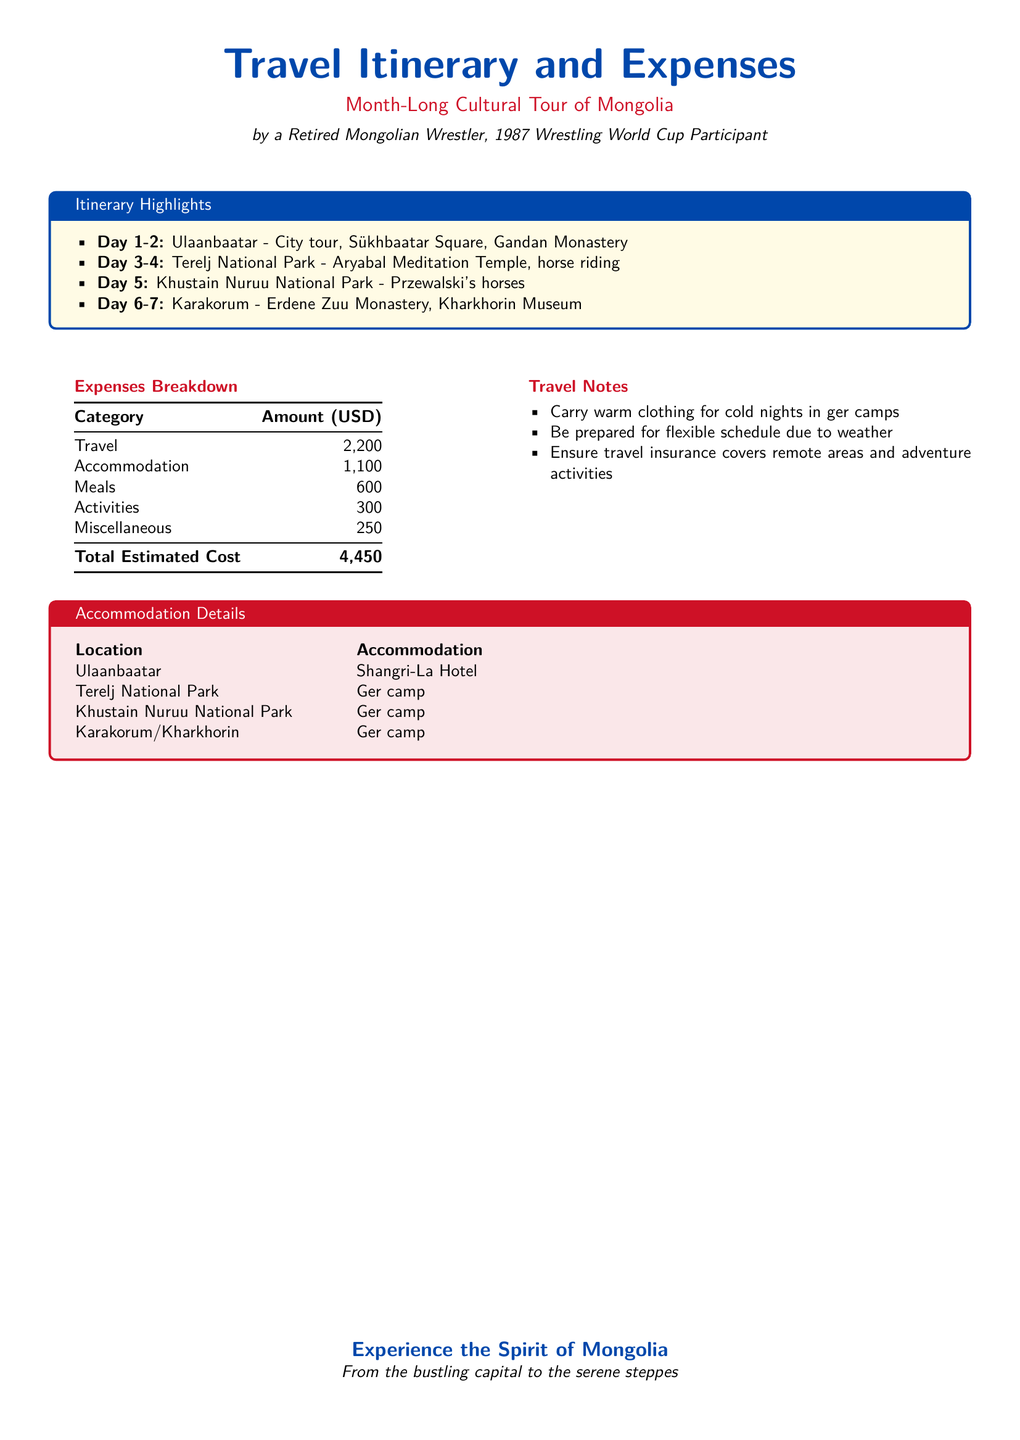What are the highlights of the itinerary? The itinerary highlights include various locations and activities over a month-long tour in Mongolia.
Answer: Ulaanbaatar, Terelj National Park, Khustain Nuruu National Park, Karakorum What is the total estimated cost for the trip? The total estimated cost is the sum of individual expense categories.
Answer: 4,450 Where will you stay in Ulaanbaatar? The accommodation details list specific places to stay during the tour.
Answer: Shangri-La Hotel How much is budgeted for meals? The expenses breakdown shows the allocation for meals during the trip.
Answer: 600 What type of accommodations are used in national parks? The document specifies the type of accommodation for certain locations within Mongolia.
Answer: Ger camp What should you carry for the trip? The travel notes advise what to prepare for the cultural tour.
Answer: Warm clothing How many days are allotted for Terelj National Park? The itinerary outlines the number of days spent at each location.
Answer: 2 Where will you see Przewalski's horses? The itinerary mentions specific locations for wildlife encounters.
Answer: Khustain Nuruu National Park What is included under miscellaneous expenses? The expenses breakdown categorizes the individual expense areas.
Answer: 250 